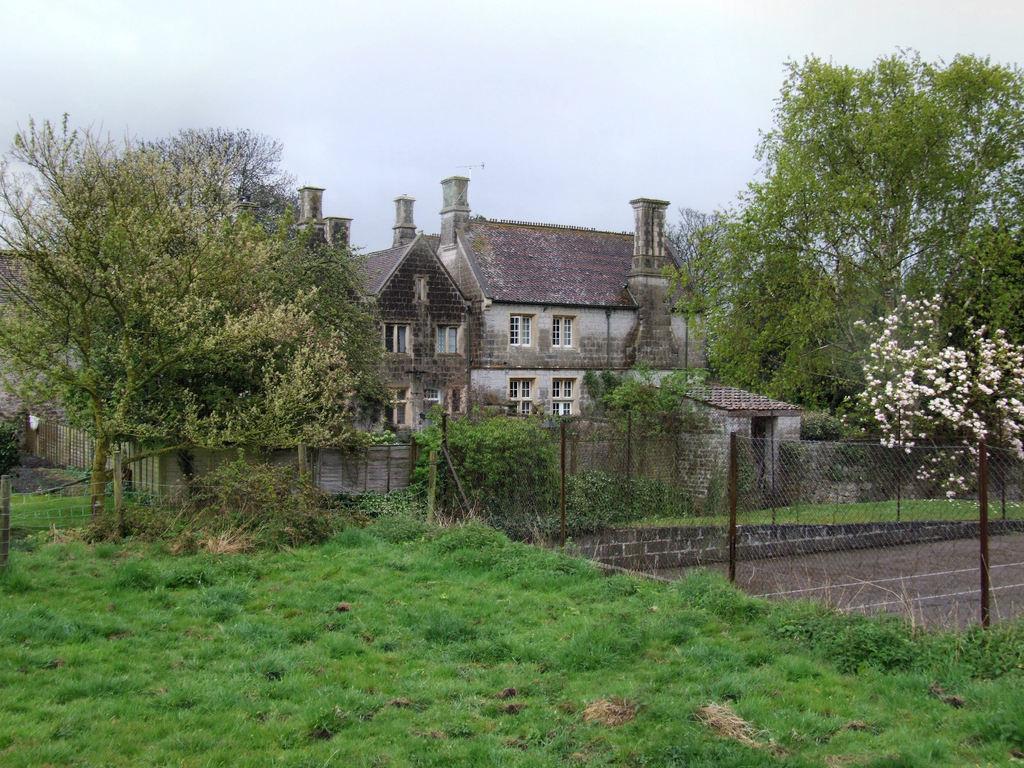In one or two sentences, can you explain what this image depicts? In this image we can see some trees, plants and grass on the ground and there is a fence. We can see a house and there is a compound wall around the house and there is a tree with flowers and at the top we can see the sky. 